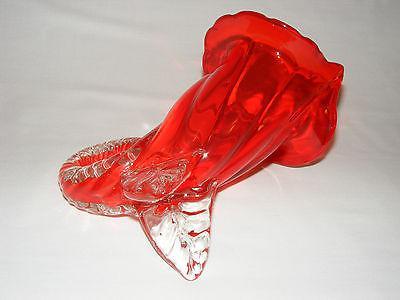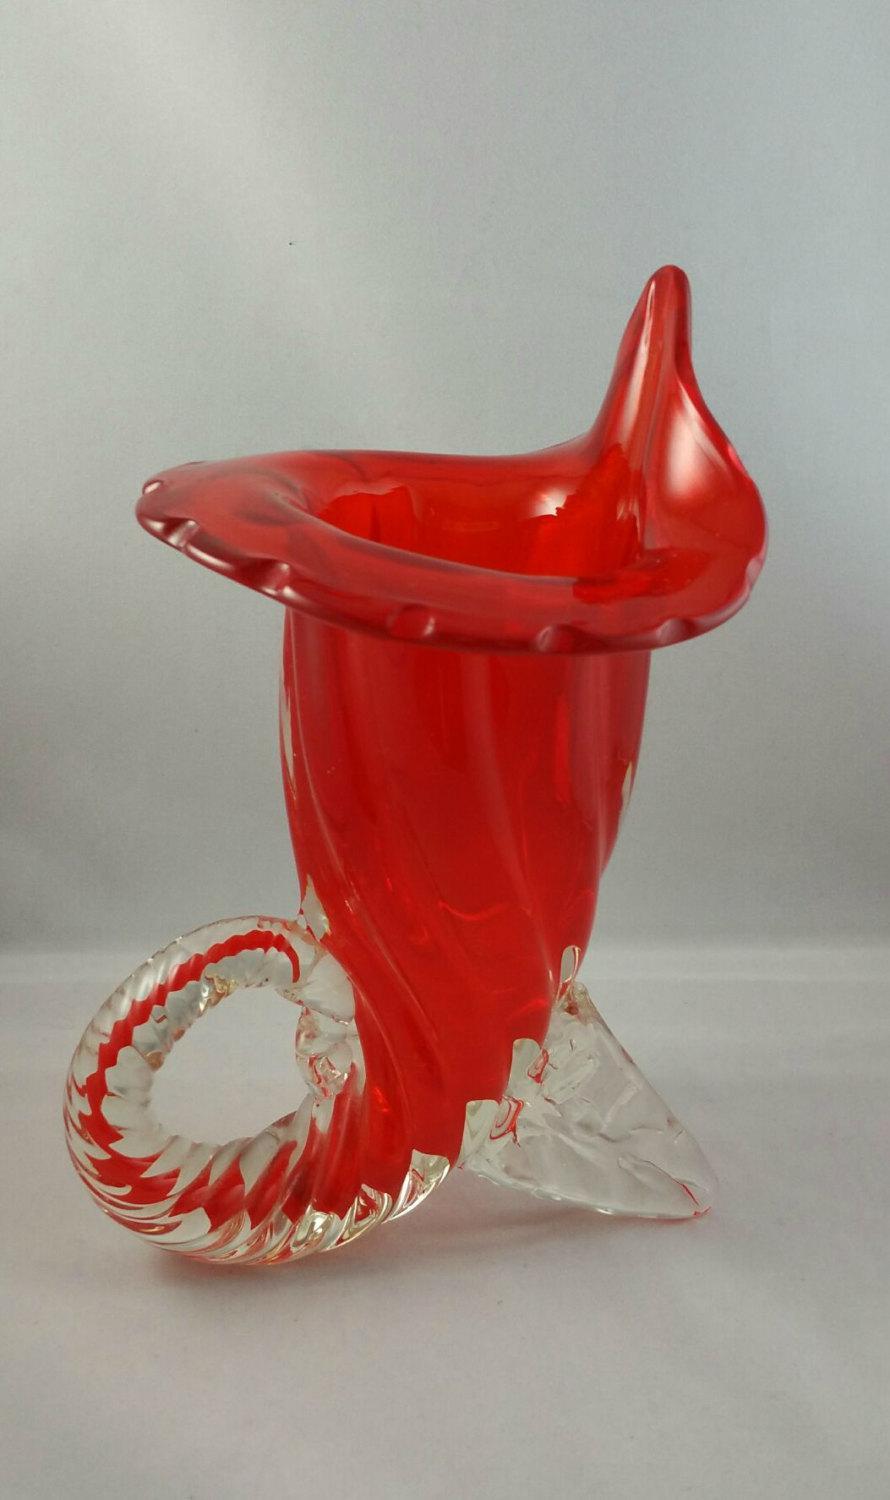The first image is the image on the left, the second image is the image on the right. For the images shown, is this caption "The vase on the right has a curled bottom." true? Answer yes or no. Yes. The first image is the image on the left, the second image is the image on the right. Examine the images to the left and right. Is the description "The vases in the two images have the same shape and color." accurate? Answer yes or no. Yes. 